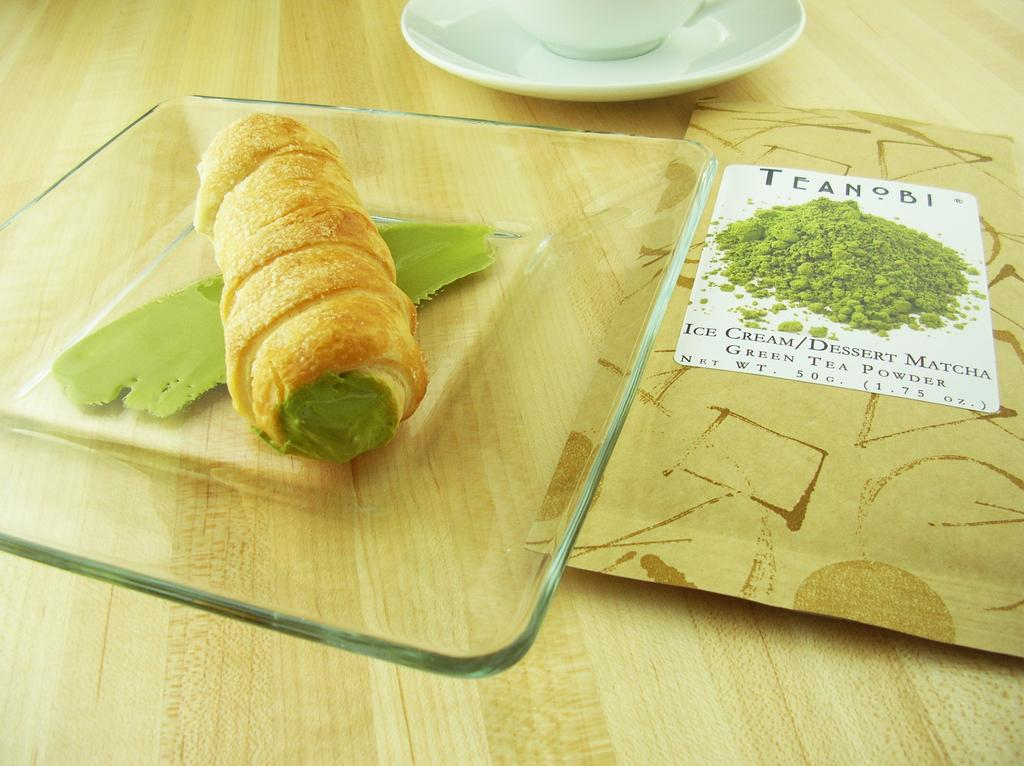What is on the glass plate in the image? There is food on a glass plate in the image. What type of dish is visible in the image? There is a white cup and saucer in the image. What is placed on the wooden table in the image? There is a packet on the wooden table in the image. Is there a servant holding the white cup and saucer in the image? There is no servant present in the image; it only shows a glass plate with food, a white cup and saucer, and a packet on a wooden table. Can you see any jellyfish in the image? There are no jellyfish present in the image. 